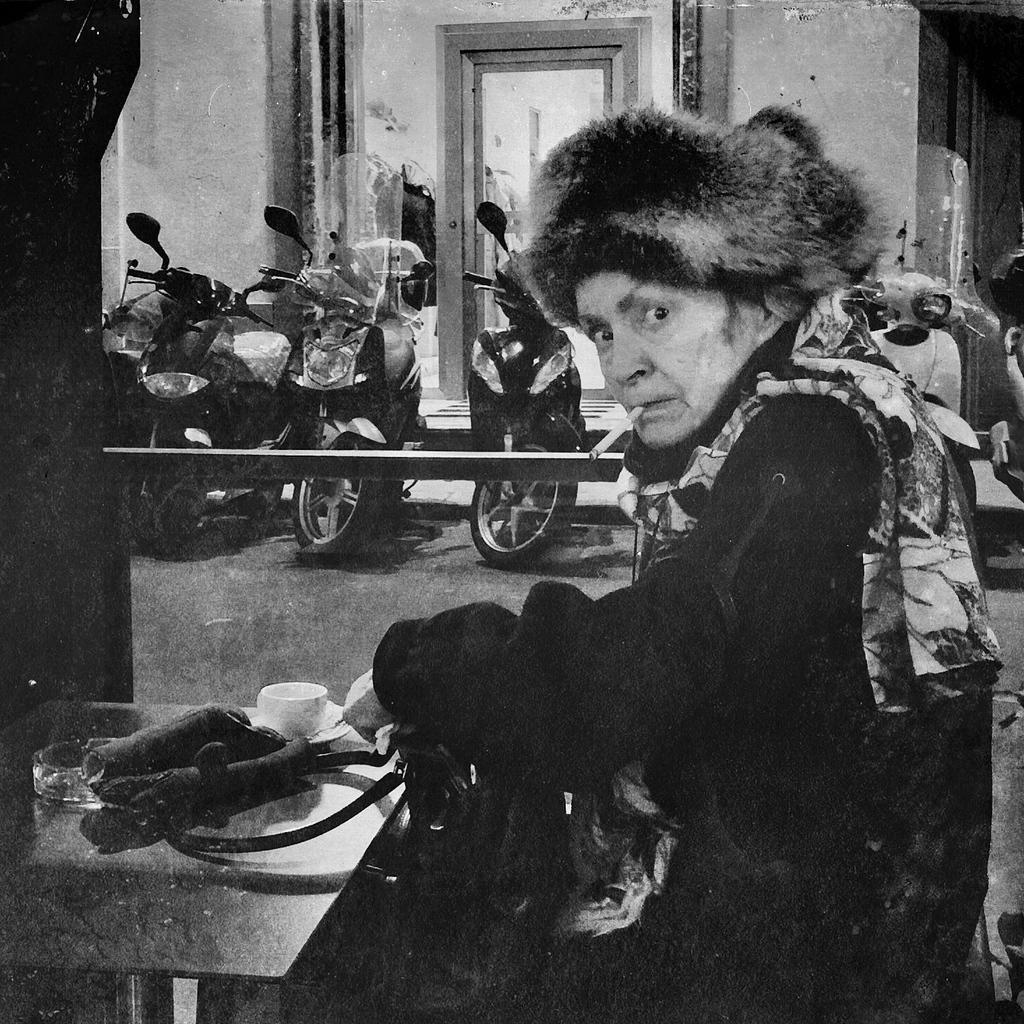Can you describe this image briefly? In this image we can see a black and white picture of a person sitting and holding a bag. On the left side of the image we can see a cup and a bowl placed on a table. In the background, we can see group of vehicles parked on the ground and a metal pole, we can also see some clothes and a building. 